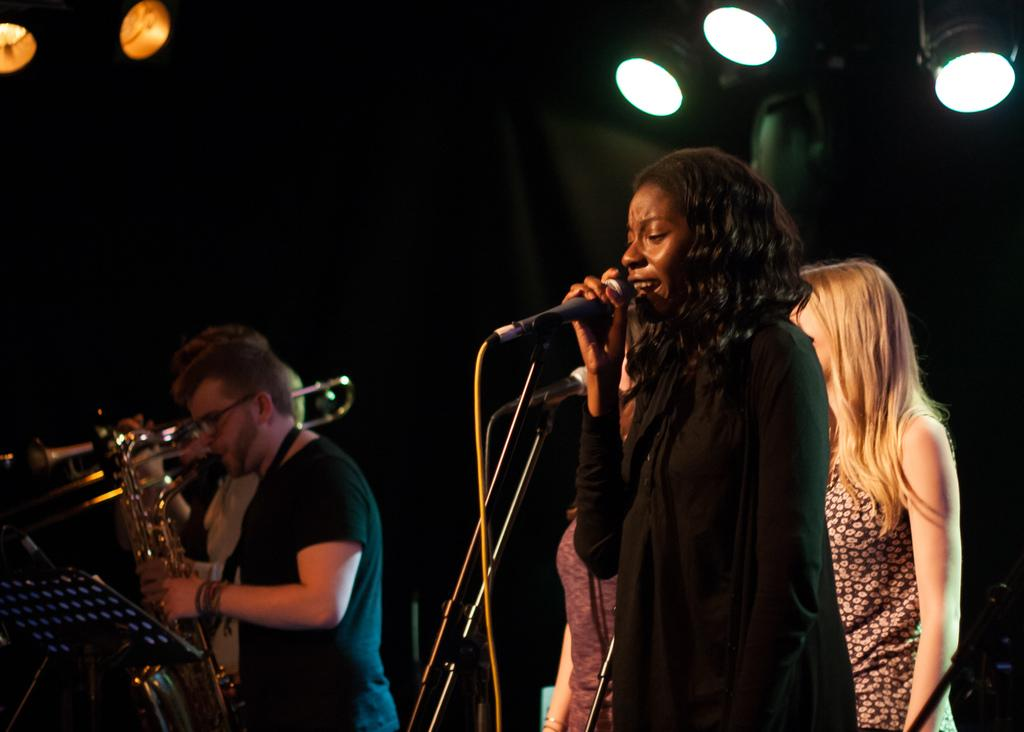What is the color of the background in the image? The background of the image is dark. What can be seen at the top of the image? There are lights visible at the top of the image. What are the people in the image doing? The people are standing and holding musical instruments. What equipment is present in the image that might be used for amplifying sound? There are microphones present in the image. What type of plants can be seen growing on the floor in the image? There are no plants visible on the floor in the image. Can you tell me how many pictures are hanging on the wall in the image? There is no mention of any pictures hanging on the wall in the image. 